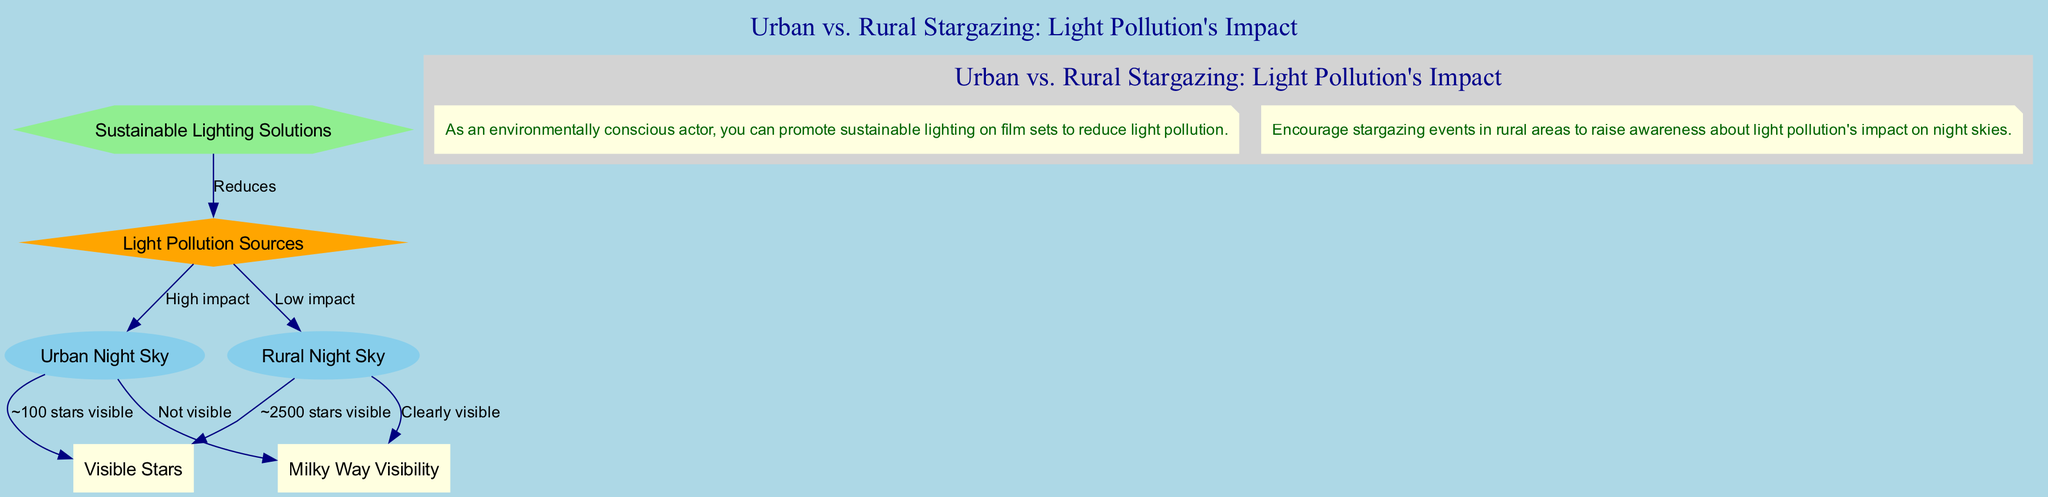What is the label of the node representing urban night sky? The diagram features a node specifically for the urban night sky with the label "Urban Night Sky".
Answer: Urban Night Sky How many stars are visible in the rural night sky? The diagram indicates that in a rural night sky, approximately 2500 stars are visible, as shown by the edge connecting the rural sky to the visible stars node.
Answer: ~2500 stars visible What is the level of light pollution's impact on urban night skies? The edge in the diagram between light pollution and the urban night sky indicates that the impact is categorized as "High impact".
Answer: High impact Is the Milky Way visible in urban night skies? According to the diagram, the edge from the urban sky to the Milky Way visibility node states that it is "Not visible" in urban areas.
Answer: Not visible What lighting solutions can reduce light pollution? The diagram shows a connection from sustainable lighting to light pollution, labeled as "Reduces", indicating that sustainable lighting solutions can mitigate light pollution.
Answer: Sustainable Lighting Solutions How many stars are visible in the urban night sky? The edge leading from the urban sky to the visible stars node states that around 100 stars are visible, providing a quantifiable comparison to the rural night sky.
Answer: ~100 stars visible What relationship is depicted between rural skies and Milky Way visibility? The diagram features an edge connecting the rural night sky to the Milky Way visibility node, indicating that the Milky Way is "Clearly visible" in rural areas, showing a stark contrast to urban conditions.
Answer: Clearly visible What role do sustainable lighting solutions play in relation to light pollution? The diagram illustrates that sustainable lighting solutions are directly linked to light pollution, where they are shown to "Reduces" its effects, highlighting the potential benefits of environmentally-friendly practices.
Answer: Reduces What type of environments display a significant difference in visible stars? By comparing the nodes for urban and rural night skies, the diagram shows a stark contrast in visible stars, with urban environments having significantly fewer stars visible compared to rural areas.
Answer: Urban vs. Rural environments 